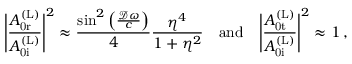<formula> <loc_0><loc_0><loc_500><loc_500>\left | \frac { A _ { 0 r } ^ { ( L ) } } { A _ { 0 i } ^ { ( L ) } } \right | ^ { 2 } \approx \frac { \sin ^ { 2 } \left ( \frac { \mathcal { D } \omega } { c } \right ) } { 4 } \frac { \eta ^ { 4 } } { 1 + \eta ^ { 2 } } \quad a n d \quad \left | \frac { A _ { 0 t } ^ { ( L ) } } { A _ { 0 i } ^ { ( L ) } } \right | ^ { 2 } \approx 1 \, ,</formula> 